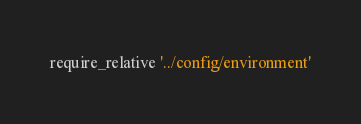Convert code to text. <code><loc_0><loc_0><loc_500><loc_500><_Ruby_>
require_relative '../config/environment'</code> 